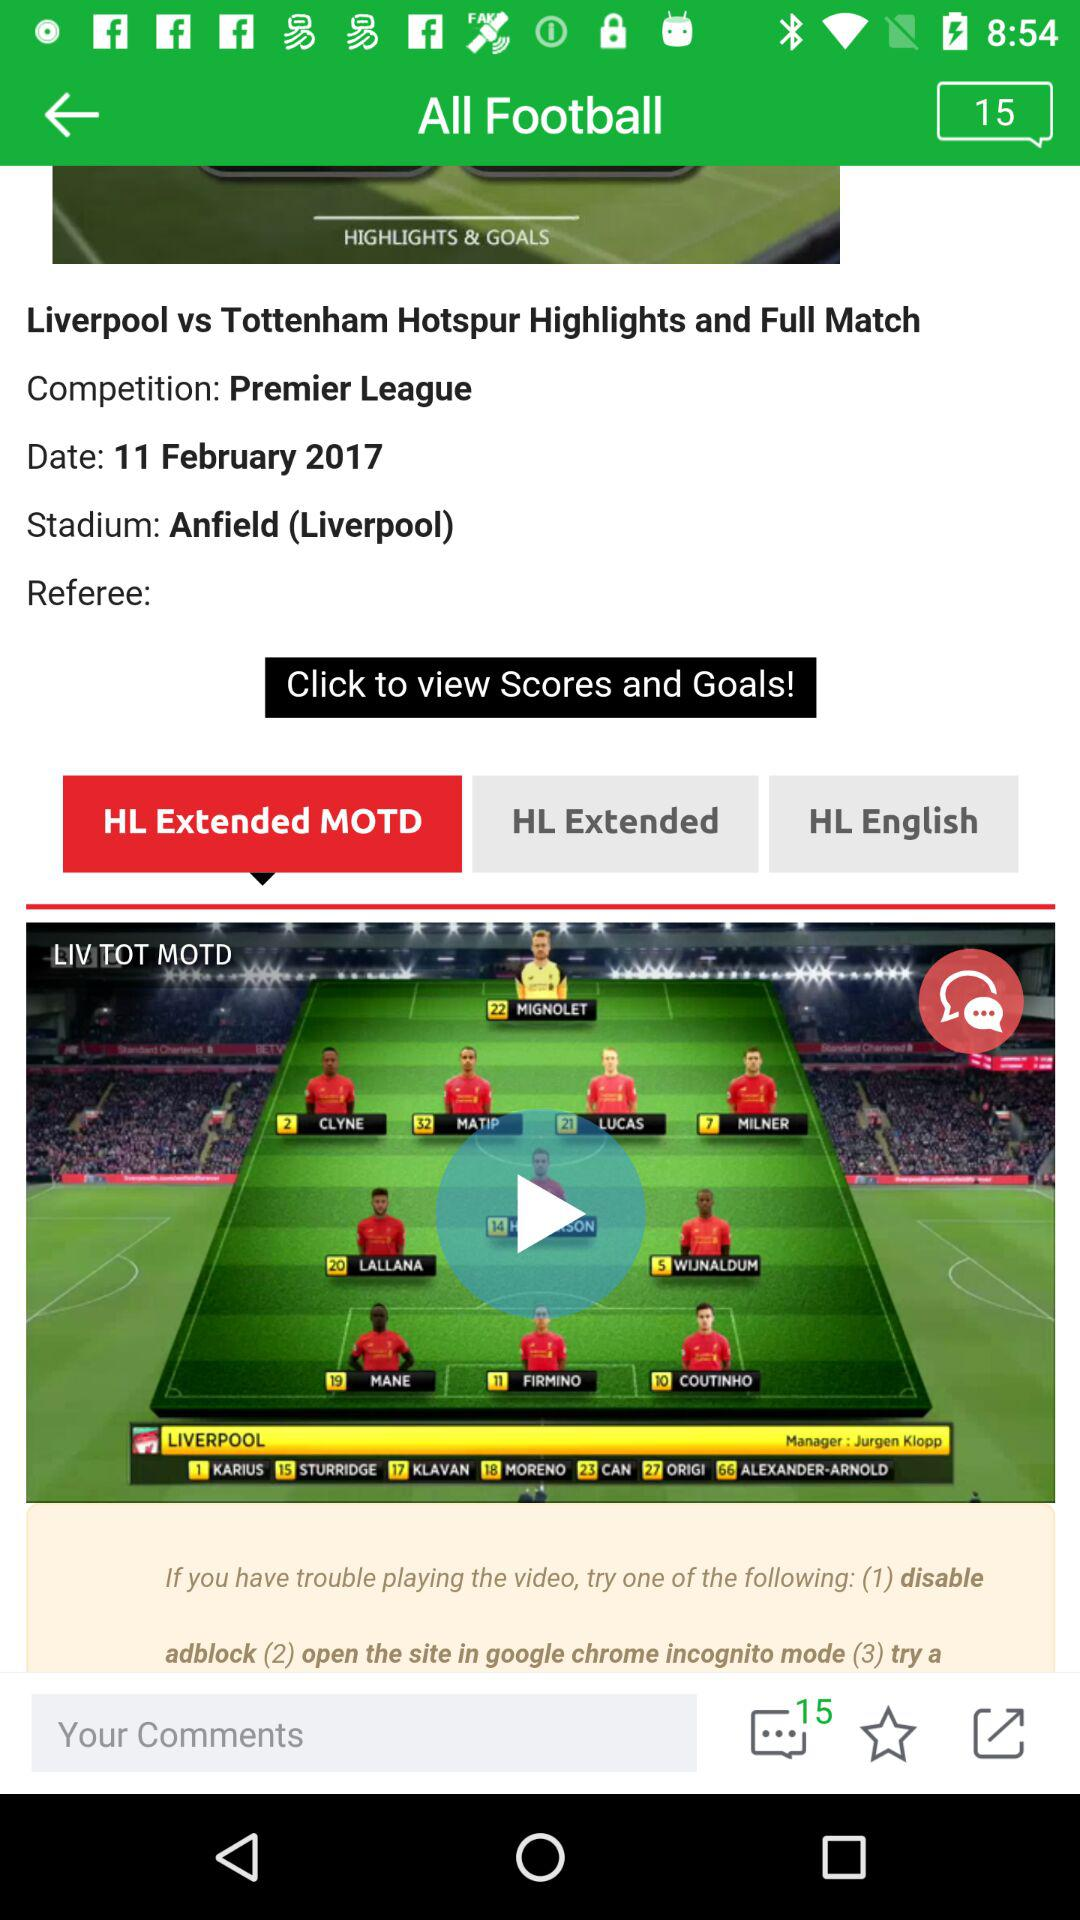What is the selected date? The selected date is February 11, 2017. 